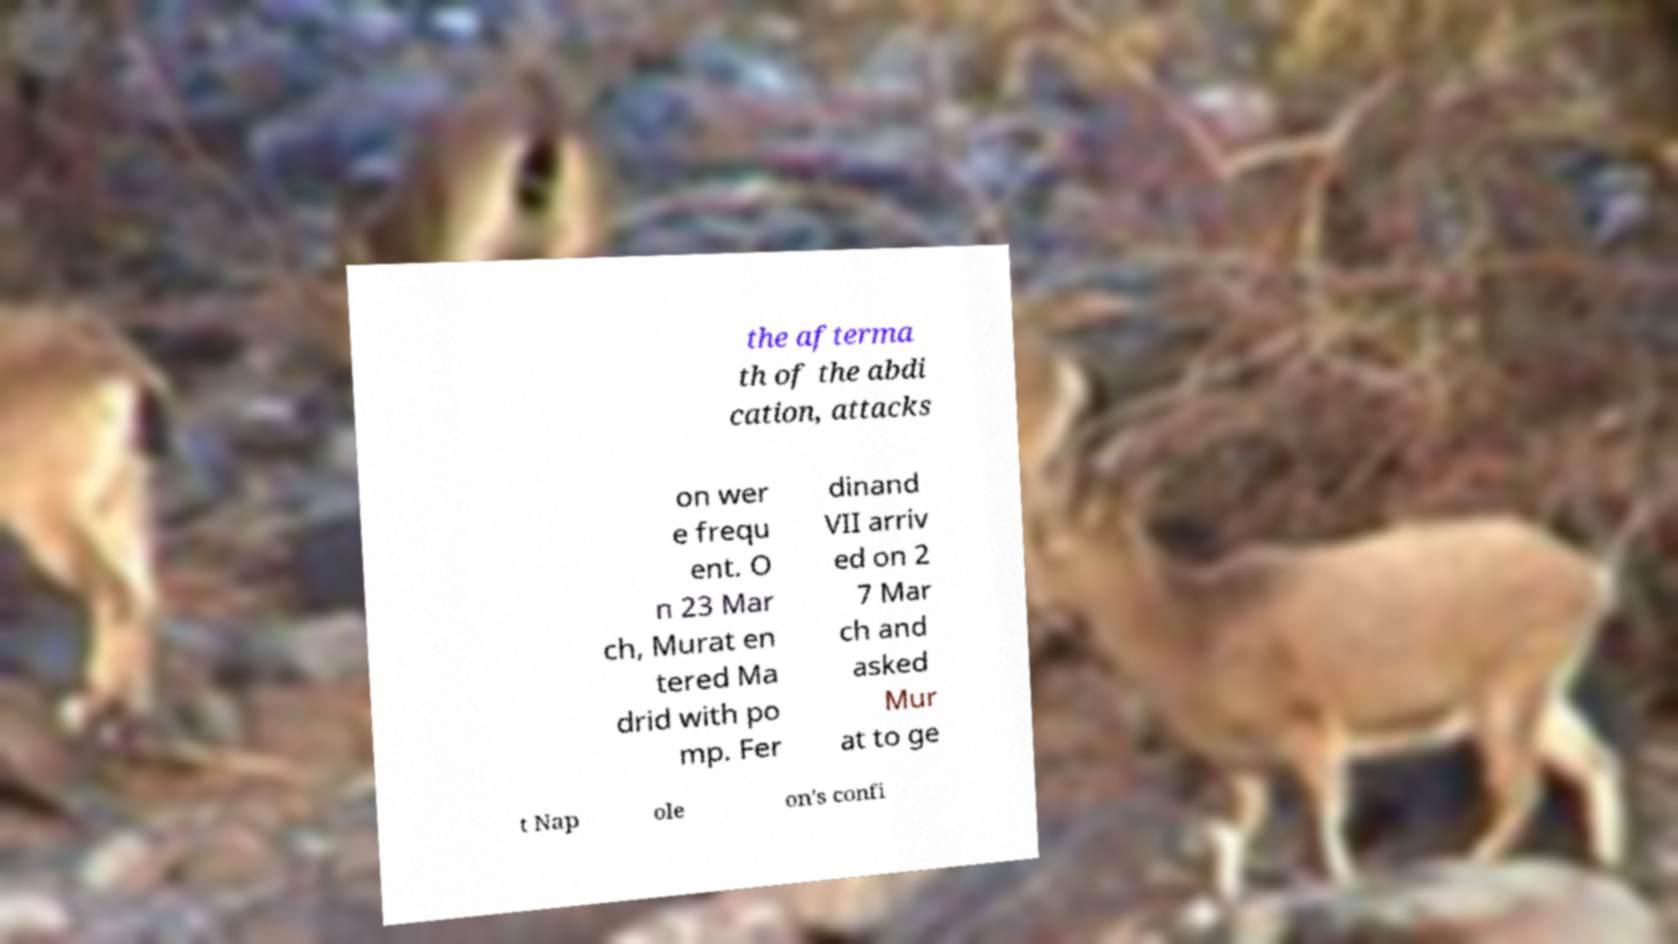There's text embedded in this image that I need extracted. Can you transcribe it verbatim? the afterma th of the abdi cation, attacks on wer e frequ ent. O n 23 Mar ch, Murat en tered Ma drid with po mp. Fer dinand VII arriv ed on 2 7 Mar ch and asked Mur at to ge t Nap ole on's confi 